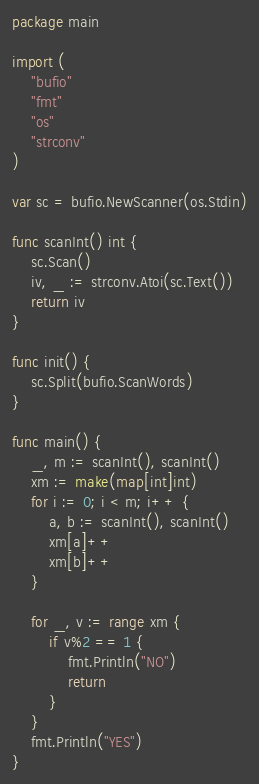<code> <loc_0><loc_0><loc_500><loc_500><_Go_>package main

import (
	"bufio"
	"fmt"
	"os"
	"strconv"
)

var sc = bufio.NewScanner(os.Stdin)

func scanInt() int {
	sc.Scan()
	iv, _ := strconv.Atoi(sc.Text())
	return iv
}

func init() {
	sc.Split(bufio.ScanWords)
}

func main() {
	_, m := scanInt(), scanInt()
	xm := make(map[int]int)
	for i := 0; i < m; i++ {
		a, b := scanInt(), scanInt()
		xm[a]++
		xm[b]++
	}

	for _, v := range xm {
		if v%2 == 1 {
			fmt.Println("NO")
			return
		}
	}
	fmt.Println("YES")
}
</code> 